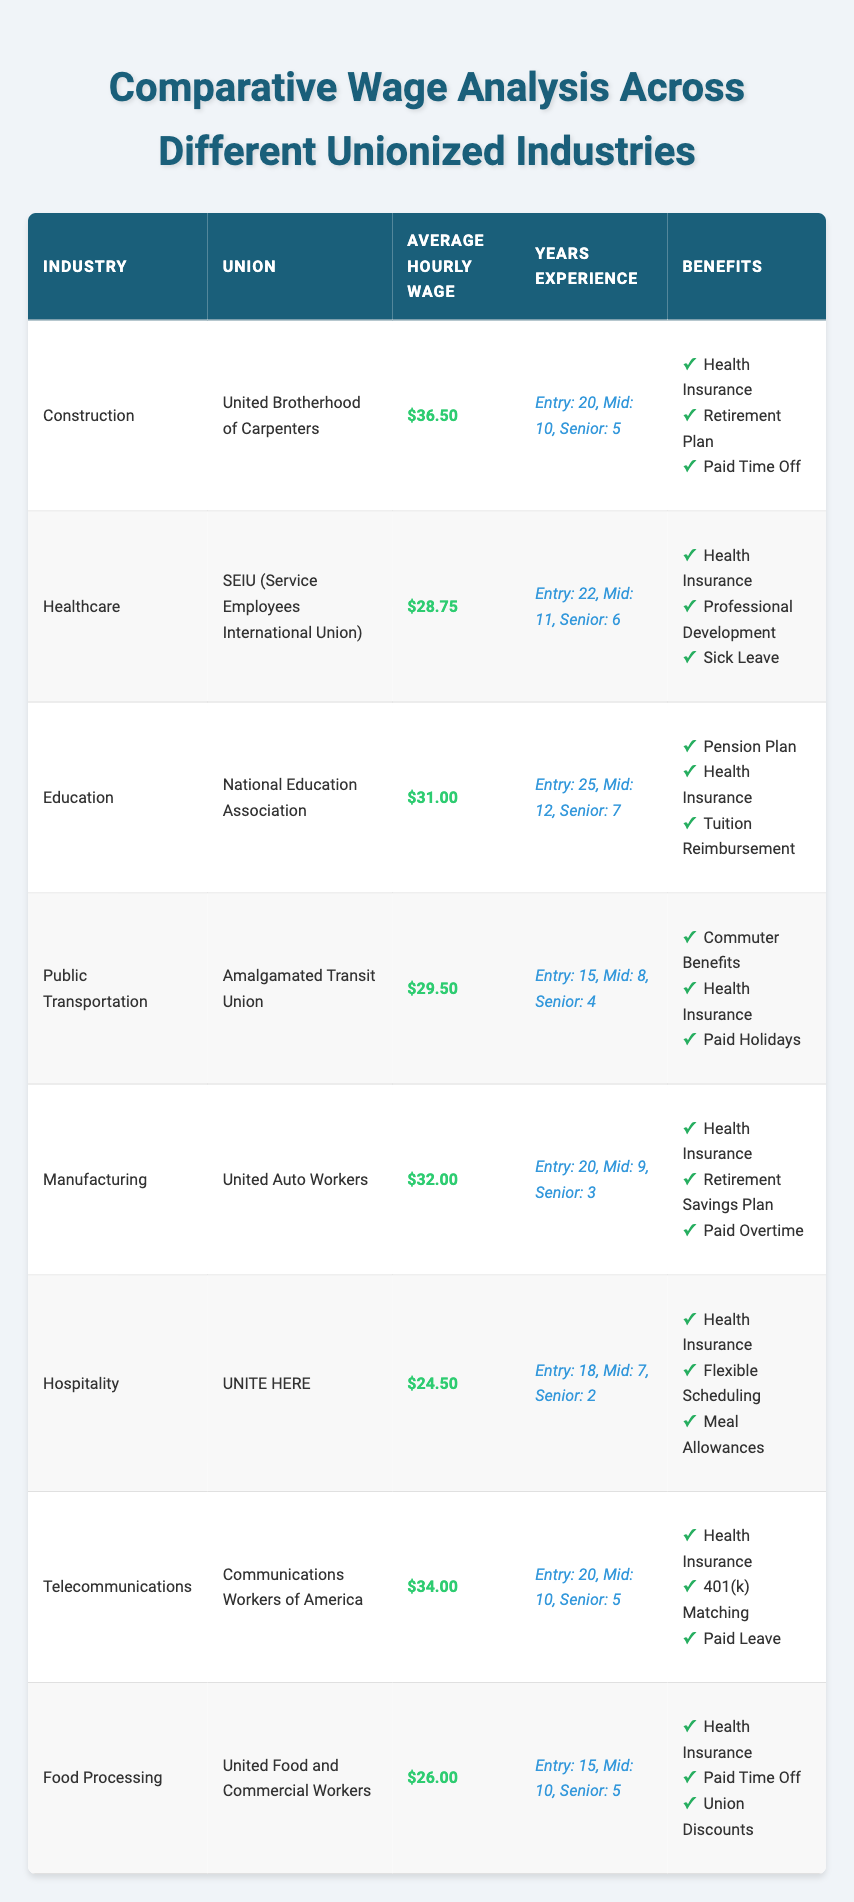What is the average hourly wage in the Construction industry? In the table, the average hourly wage for the Construction industry listed under the United Brotherhood of Carpenters is $36.50.
Answer: $36.50 Which industry has the highest average hourly wage? By comparing the average hourly wages listed in the table, Construction with $36.50 has the highest wage among all the industries.
Answer: Construction How many years of experience is required for mid-level Construction workers? The table indicates that mid-level workers in the Construction industry require 10 years of experience.
Answer: 10 Are Health Insurance benefits provided in the Hospitality industry? Referring to the Hospitality row in the table, it shows that Health Insurance is indeed one of the benefits listed for this industry.
Answer: Yes What is the difference between the average hourly wages of Healthcare and Food Processing? The average hourly wage for Healthcare is $28.75, and for Food Processing, it is $26.00. The difference can be calculated as $28.75 - $26.00 = $2.75.
Answer: $2.75 Calculate the average years of experience for entry-level workers across all industries. To determine this, sum the entry-level years of experience: 20 (Construction) + 22 (Healthcare) + 25 (Education) + 15 (Public Transportation) + 20 (Manufacturing) + 18 (Hospitality) + 20 (Telecommunications) + 15 (Food Processing) =  155. Divide by the number of industries (8): 155 / 8 = 19.375, rounded to two decimal places is 19.38.
Answer: 19.38 Which union provides the benefit of Tuition Reimbursement? The Education row in the table states that the National Education Association offers Tuition Reimbursement, among other benefits.
Answer: National Education Association How many total benefits are listed for the Manufacturing industry? In the Manufacturing row of the table, there are three benefits listed: Health Insurance, Retirement Savings Plan, and Paid Overtime, making the total three.
Answer: 3 Which industry has the lowest average hourly wage? By reviewing the average hourly wages, Hospitality is the lowest at $24.50.
Answer: Hospitality What is the average hourly wage for mid-level workers in all the listed industries? The mid-level wages can be summarized as follows: Construction ($36.50), Healthcare ($28.75), Education ($31.00), Public Transportation ($29.50), Manufacturing ($32.00), Hospitality ($24.50), Telecommunications ($34.00), and Food Processing ($26.00). The average is calculated by summing these values and dividing by the number of industries. The sum is $36.50 + $28.75 + $31.00 + $29.50 + $32.00 + $24.50 + $34.00 + $26.00 = $  308.25, divided by 8 gives $38.53.
Answer: $38.53 